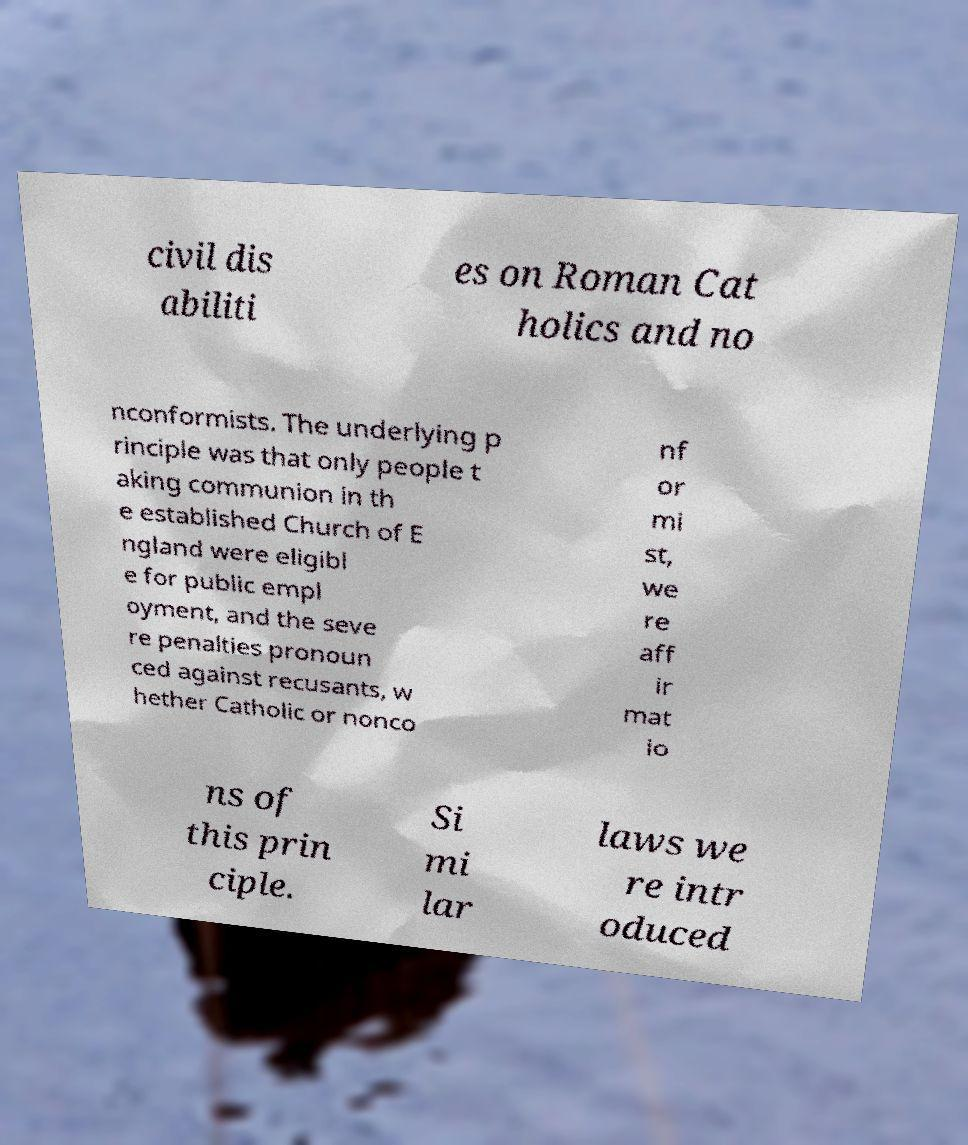For documentation purposes, I need the text within this image transcribed. Could you provide that? civil dis abiliti es on Roman Cat holics and no nconformists. The underlying p rinciple was that only people t aking communion in th e established Church of E ngland were eligibl e for public empl oyment, and the seve re penalties pronoun ced against recusants, w hether Catholic or nonco nf or mi st, we re aff ir mat io ns of this prin ciple. Si mi lar laws we re intr oduced 